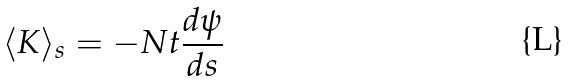Convert formula to latex. <formula><loc_0><loc_0><loc_500><loc_500>\langle K \rangle _ { s } = - N t \frac { d \psi } { d s }</formula> 